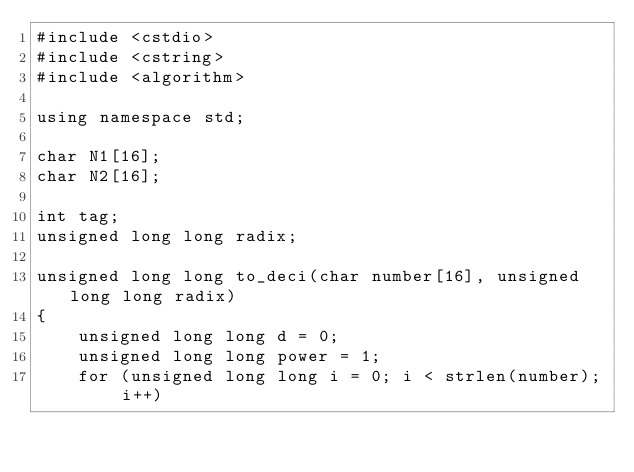Convert code to text. <code><loc_0><loc_0><loc_500><loc_500><_C++_>#include <cstdio>
#include <cstring>
#include <algorithm>

using namespace std;

char N1[16];
char N2[16];

int tag;
unsigned long long radix;

unsigned long long to_deci(char number[16], unsigned long long radix)
{
    unsigned long long d = 0;
    unsigned long long power = 1;
    for (unsigned long long i = 0; i < strlen(number); i++)</code> 